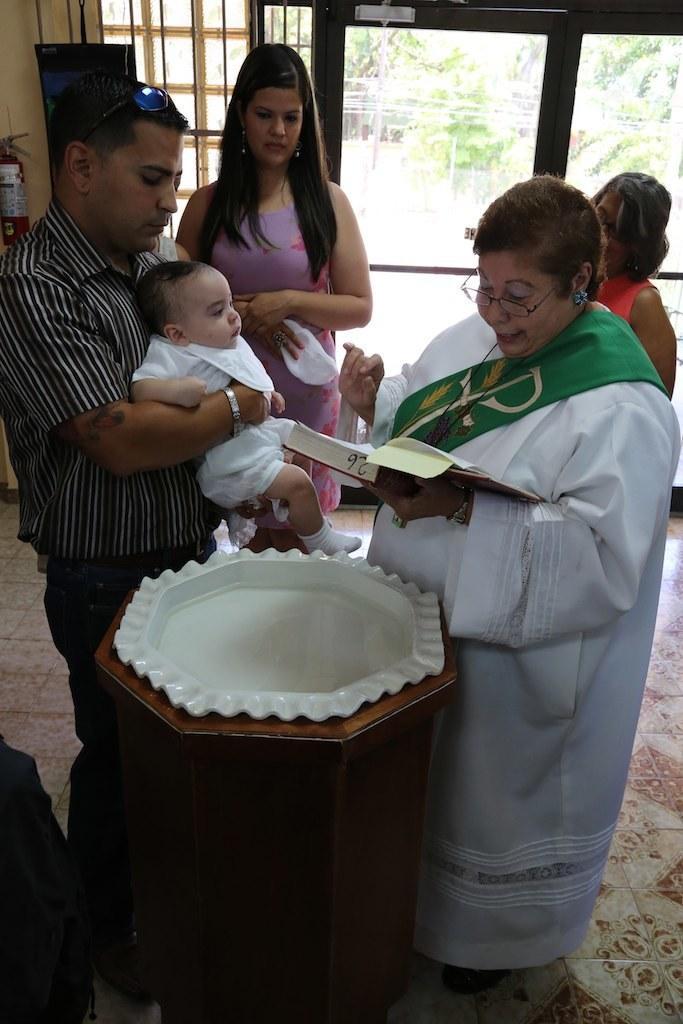Please provide a concise description of this image. On the right side of the image we can see a lady standing and holding a book, next to her there is a man standing and holding a baby. In the background there are people and a door. We can see a window. There is a fire extinguisher. At the bottom there is a stand and we can see a tub placed on the stand. 